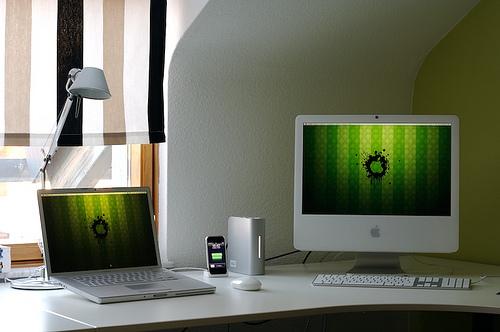How many mouses do you see?
Write a very short answer. 1. What is on the computer screen?
Concise answer only. Apple. What is securing the laptop?
Be succinct. Nothing. Is it night time?
Write a very short answer. No. Do both screens have the same image?
Give a very brief answer. Yes. 